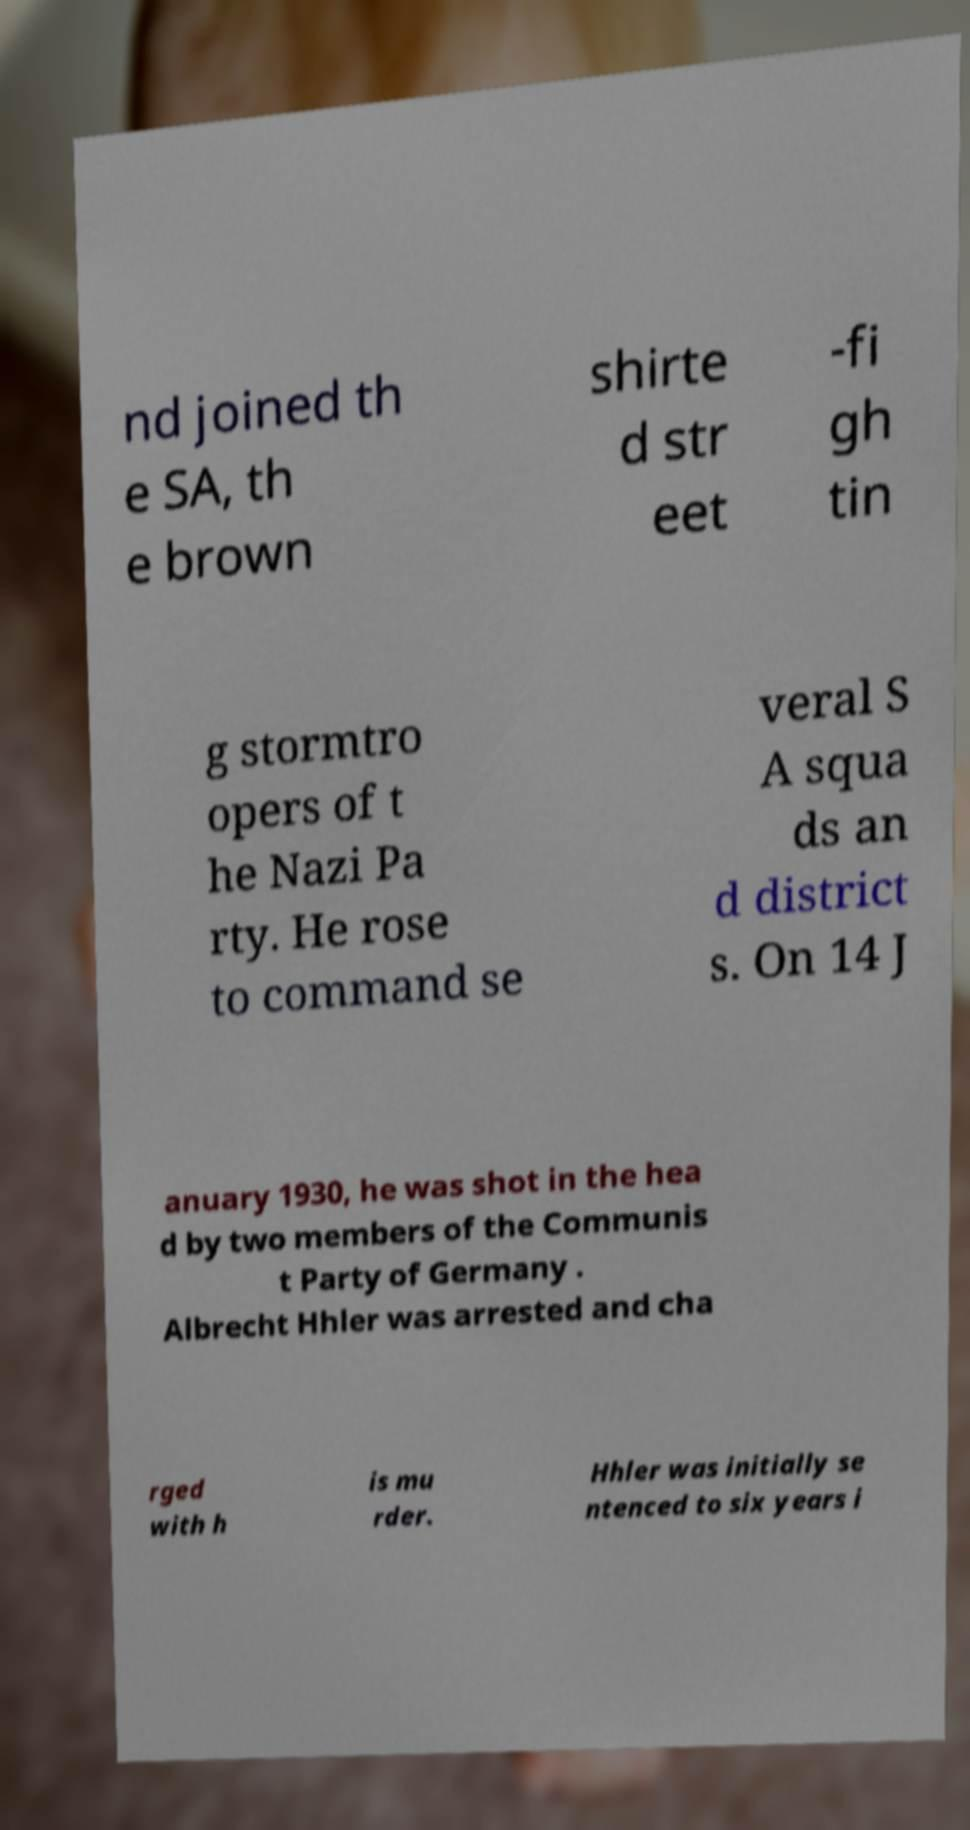Could you extract and type out the text from this image? nd joined th e SA, th e brown shirte d str eet -fi gh tin g stormtro opers of t he Nazi Pa rty. He rose to command se veral S A squa ds an d district s. On 14 J anuary 1930, he was shot in the hea d by two members of the Communis t Party of Germany . Albrecht Hhler was arrested and cha rged with h is mu rder. Hhler was initially se ntenced to six years i 